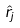Convert formula to latex. <formula><loc_0><loc_0><loc_500><loc_500>\hat { r } _ { j }</formula> 